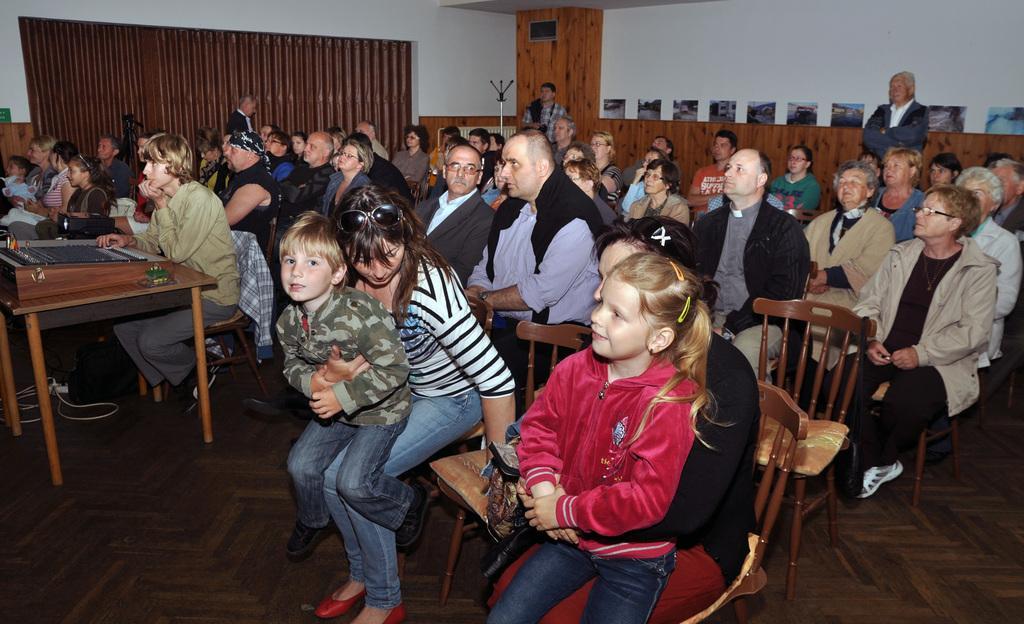In one or two sentences, can you explain what this image depicts? In the image we can see there are lot of people who are sitting on chair. 